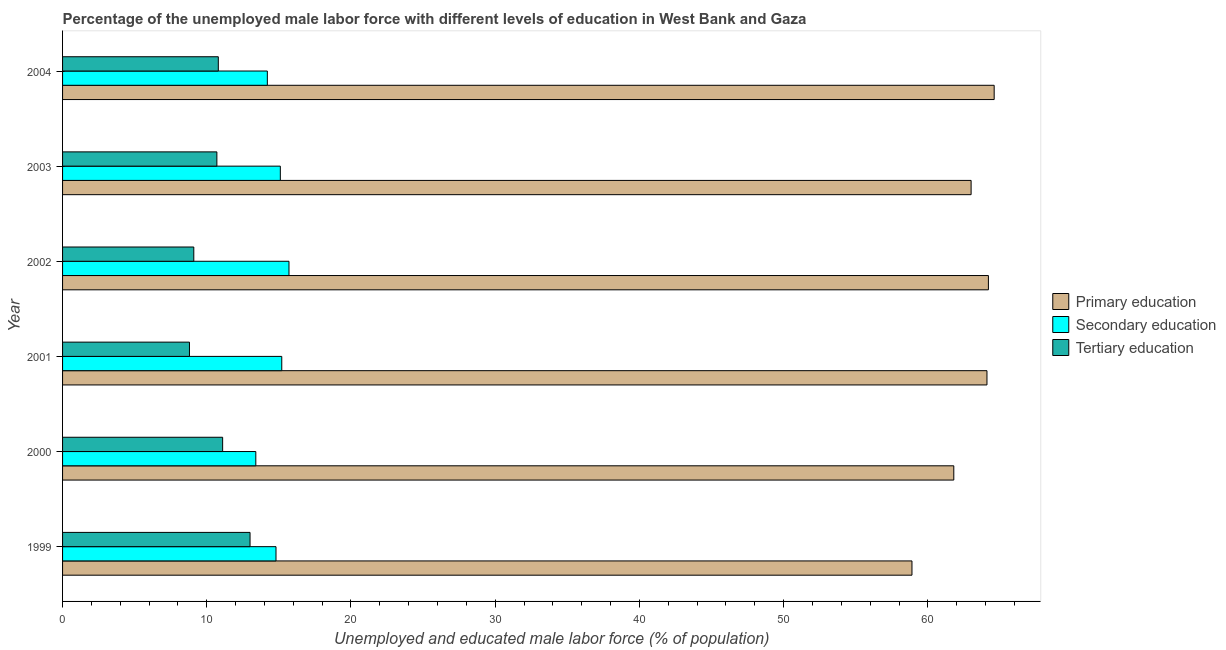How many bars are there on the 2nd tick from the bottom?
Offer a terse response. 3. What is the percentage of male labor force who received primary education in 1999?
Offer a very short reply. 58.9. Across all years, what is the maximum percentage of male labor force who received primary education?
Your answer should be very brief. 64.6. Across all years, what is the minimum percentage of male labor force who received tertiary education?
Provide a short and direct response. 8.8. In which year was the percentage of male labor force who received primary education minimum?
Offer a terse response. 1999. What is the total percentage of male labor force who received tertiary education in the graph?
Offer a terse response. 63.5. What is the difference between the percentage of male labor force who received secondary education in 1999 and that in 2000?
Make the answer very short. 1.4. What is the difference between the percentage of male labor force who received secondary education in 2003 and the percentage of male labor force who received tertiary education in 2004?
Ensure brevity in your answer.  4.3. What is the average percentage of male labor force who received secondary education per year?
Provide a short and direct response. 14.73. In the year 2003, what is the difference between the percentage of male labor force who received tertiary education and percentage of male labor force who received primary education?
Provide a short and direct response. -52.3. What is the ratio of the percentage of male labor force who received secondary education in 2000 to that in 2003?
Ensure brevity in your answer.  0.89. Is the percentage of male labor force who received primary education in 2000 less than that in 2001?
Your answer should be compact. Yes. What is the difference between the highest and the second highest percentage of male labor force who received secondary education?
Make the answer very short. 0.5. In how many years, is the percentage of male labor force who received secondary education greater than the average percentage of male labor force who received secondary education taken over all years?
Keep it short and to the point. 4. Is the sum of the percentage of male labor force who received tertiary education in 2001 and 2002 greater than the maximum percentage of male labor force who received primary education across all years?
Provide a short and direct response. No. What does the 3rd bar from the top in 2002 represents?
Ensure brevity in your answer.  Primary education. What does the 3rd bar from the bottom in 2004 represents?
Provide a short and direct response. Tertiary education. Is it the case that in every year, the sum of the percentage of male labor force who received primary education and percentage of male labor force who received secondary education is greater than the percentage of male labor force who received tertiary education?
Provide a succinct answer. Yes. Are all the bars in the graph horizontal?
Keep it short and to the point. Yes. Are the values on the major ticks of X-axis written in scientific E-notation?
Offer a very short reply. No. Does the graph contain grids?
Ensure brevity in your answer.  No. How many legend labels are there?
Keep it short and to the point. 3. How are the legend labels stacked?
Offer a terse response. Vertical. What is the title of the graph?
Provide a succinct answer. Percentage of the unemployed male labor force with different levels of education in West Bank and Gaza. Does "Wage workers" appear as one of the legend labels in the graph?
Keep it short and to the point. No. What is the label or title of the X-axis?
Offer a terse response. Unemployed and educated male labor force (% of population). What is the Unemployed and educated male labor force (% of population) of Primary education in 1999?
Provide a short and direct response. 58.9. What is the Unemployed and educated male labor force (% of population) of Secondary education in 1999?
Your answer should be compact. 14.8. What is the Unemployed and educated male labor force (% of population) of Primary education in 2000?
Your response must be concise. 61.8. What is the Unemployed and educated male labor force (% of population) of Secondary education in 2000?
Keep it short and to the point. 13.4. What is the Unemployed and educated male labor force (% of population) in Tertiary education in 2000?
Offer a terse response. 11.1. What is the Unemployed and educated male labor force (% of population) in Primary education in 2001?
Provide a short and direct response. 64.1. What is the Unemployed and educated male labor force (% of population) of Secondary education in 2001?
Provide a succinct answer. 15.2. What is the Unemployed and educated male labor force (% of population) of Tertiary education in 2001?
Ensure brevity in your answer.  8.8. What is the Unemployed and educated male labor force (% of population) in Primary education in 2002?
Your answer should be very brief. 64.2. What is the Unemployed and educated male labor force (% of population) of Secondary education in 2002?
Make the answer very short. 15.7. What is the Unemployed and educated male labor force (% of population) in Tertiary education in 2002?
Provide a succinct answer. 9.1. What is the Unemployed and educated male labor force (% of population) in Primary education in 2003?
Provide a short and direct response. 63. What is the Unemployed and educated male labor force (% of population) in Secondary education in 2003?
Keep it short and to the point. 15.1. What is the Unemployed and educated male labor force (% of population) of Tertiary education in 2003?
Make the answer very short. 10.7. What is the Unemployed and educated male labor force (% of population) of Primary education in 2004?
Keep it short and to the point. 64.6. What is the Unemployed and educated male labor force (% of population) in Secondary education in 2004?
Keep it short and to the point. 14.2. What is the Unemployed and educated male labor force (% of population) in Tertiary education in 2004?
Provide a succinct answer. 10.8. Across all years, what is the maximum Unemployed and educated male labor force (% of population) of Primary education?
Make the answer very short. 64.6. Across all years, what is the maximum Unemployed and educated male labor force (% of population) in Secondary education?
Offer a very short reply. 15.7. Across all years, what is the maximum Unemployed and educated male labor force (% of population) in Tertiary education?
Keep it short and to the point. 13. Across all years, what is the minimum Unemployed and educated male labor force (% of population) in Primary education?
Give a very brief answer. 58.9. Across all years, what is the minimum Unemployed and educated male labor force (% of population) of Secondary education?
Provide a short and direct response. 13.4. Across all years, what is the minimum Unemployed and educated male labor force (% of population) in Tertiary education?
Give a very brief answer. 8.8. What is the total Unemployed and educated male labor force (% of population) of Primary education in the graph?
Offer a terse response. 376.6. What is the total Unemployed and educated male labor force (% of population) in Secondary education in the graph?
Keep it short and to the point. 88.4. What is the total Unemployed and educated male labor force (% of population) in Tertiary education in the graph?
Provide a succinct answer. 63.5. What is the difference between the Unemployed and educated male labor force (% of population) in Primary education in 1999 and that in 2000?
Offer a very short reply. -2.9. What is the difference between the Unemployed and educated male labor force (% of population) of Secondary education in 1999 and that in 2000?
Provide a succinct answer. 1.4. What is the difference between the Unemployed and educated male labor force (% of population) in Tertiary education in 1999 and that in 2000?
Your answer should be very brief. 1.9. What is the difference between the Unemployed and educated male labor force (% of population) in Primary education in 1999 and that in 2001?
Make the answer very short. -5.2. What is the difference between the Unemployed and educated male labor force (% of population) in Secondary education in 1999 and that in 2001?
Ensure brevity in your answer.  -0.4. What is the difference between the Unemployed and educated male labor force (% of population) of Tertiary education in 1999 and that in 2001?
Provide a short and direct response. 4.2. What is the difference between the Unemployed and educated male labor force (% of population) of Primary education in 1999 and that in 2002?
Provide a succinct answer. -5.3. What is the difference between the Unemployed and educated male labor force (% of population) in Secondary education in 1999 and that in 2003?
Provide a succinct answer. -0.3. What is the difference between the Unemployed and educated male labor force (% of population) in Tertiary education in 1999 and that in 2004?
Your answer should be very brief. 2.2. What is the difference between the Unemployed and educated male labor force (% of population) of Primary education in 2000 and that in 2002?
Provide a succinct answer. -2.4. What is the difference between the Unemployed and educated male labor force (% of population) of Tertiary education in 2000 and that in 2002?
Give a very brief answer. 2. What is the difference between the Unemployed and educated male labor force (% of population) of Primary education in 2000 and that in 2003?
Offer a very short reply. -1.2. What is the difference between the Unemployed and educated male labor force (% of population) in Primary education in 2000 and that in 2004?
Provide a short and direct response. -2.8. What is the difference between the Unemployed and educated male labor force (% of population) of Secondary education in 2001 and that in 2002?
Provide a succinct answer. -0.5. What is the difference between the Unemployed and educated male labor force (% of population) of Tertiary education in 2001 and that in 2002?
Give a very brief answer. -0.3. What is the difference between the Unemployed and educated male labor force (% of population) in Tertiary education in 2001 and that in 2004?
Keep it short and to the point. -2. What is the difference between the Unemployed and educated male labor force (% of population) in Primary education in 2002 and that in 2003?
Give a very brief answer. 1.2. What is the difference between the Unemployed and educated male labor force (% of population) in Secondary education in 2002 and that in 2003?
Make the answer very short. 0.6. What is the difference between the Unemployed and educated male labor force (% of population) in Tertiary education in 2002 and that in 2003?
Provide a short and direct response. -1.6. What is the difference between the Unemployed and educated male labor force (% of population) of Primary education in 2002 and that in 2004?
Offer a terse response. -0.4. What is the difference between the Unemployed and educated male labor force (% of population) in Secondary education in 2002 and that in 2004?
Your answer should be compact. 1.5. What is the difference between the Unemployed and educated male labor force (% of population) of Tertiary education in 2002 and that in 2004?
Provide a succinct answer. -1.7. What is the difference between the Unemployed and educated male labor force (% of population) in Secondary education in 2003 and that in 2004?
Keep it short and to the point. 0.9. What is the difference between the Unemployed and educated male labor force (% of population) of Primary education in 1999 and the Unemployed and educated male labor force (% of population) of Secondary education in 2000?
Offer a terse response. 45.5. What is the difference between the Unemployed and educated male labor force (% of population) of Primary education in 1999 and the Unemployed and educated male labor force (% of population) of Tertiary education in 2000?
Provide a short and direct response. 47.8. What is the difference between the Unemployed and educated male labor force (% of population) of Primary education in 1999 and the Unemployed and educated male labor force (% of population) of Secondary education in 2001?
Keep it short and to the point. 43.7. What is the difference between the Unemployed and educated male labor force (% of population) in Primary education in 1999 and the Unemployed and educated male labor force (% of population) in Tertiary education in 2001?
Keep it short and to the point. 50.1. What is the difference between the Unemployed and educated male labor force (% of population) of Primary education in 1999 and the Unemployed and educated male labor force (% of population) of Secondary education in 2002?
Give a very brief answer. 43.2. What is the difference between the Unemployed and educated male labor force (% of population) of Primary education in 1999 and the Unemployed and educated male labor force (% of population) of Tertiary education in 2002?
Give a very brief answer. 49.8. What is the difference between the Unemployed and educated male labor force (% of population) of Secondary education in 1999 and the Unemployed and educated male labor force (% of population) of Tertiary education in 2002?
Offer a terse response. 5.7. What is the difference between the Unemployed and educated male labor force (% of population) in Primary education in 1999 and the Unemployed and educated male labor force (% of population) in Secondary education in 2003?
Offer a terse response. 43.8. What is the difference between the Unemployed and educated male labor force (% of population) of Primary education in 1999 and the Unemployed and educated male labor force (% of population) of Tertiary education in 2003?
Your answer should be compact. 48.2. What is the difference between the Unemployed and educated male labor force (% of population) of Primary education in 1999 and the Unemployed and educated male labor force (% of population) of Secondary education in 2004?
Provide a succinct answer. 44.7. What is the difference between the Unemployed and educated male labor force (% of population) in Primary education in 1999 and the Unemployed and educated male labor force (% of population) in Tertiary education in 2004?
Give a very brief answer. 48.1. What is the difference between the Unemployed and educated male labor force (% of population) of Secondary education in 1999 and the Unemployed and educated male labor force (% of population) of Tertiary education in 2004?
Ensure brevity in your answer.  4. What is the difference between the Unemployed and educated male labor force (% of population) in Primary education in 2000 and the Unemployed and educated male labor force (% of population) in Secondary education in 2001?
Offer a very short reply. 46.6. What is the difference between the Unemployed and educated male labor force (% of population) in Primary education in 2000 and the Unemployed and educated male labor force (% of population) in Secondary education in 2002?
Provide a short and direct response. 46.1. What is the difference between the Unemployed and educated male labor force (% of population) of Primary education in 2000 and the Unemployed and educated male labor force (% of population) of Tertiary education in 2002?
Offer a terse response. 52.7. What is the difference between the Unemployed and educated male labor force (% of population) in Primary education in 2000 and the Unemployed and educated male labor force (% of population) in Secondary education in 2003?
Offer a very short reply. 46.7. What is the difference between the Unemployed and educated male labor force (% of population) in Primary education in 2000 and the Unemployed and educated male labor force (% of population) in Tertiary education in 2003?
Provide a succinct answer. 51.1. What is the difference between the Unemployed and educated male labor force (% of population) in Primary education in 2000 and the Unemployed and educated male labor force (% of population) in Secondary education in 2004?
Your answer should be compact. 47.6. What is the difference between the Unemployed and educated male labor force (% of population) of Primary education in 2001 and the Unemployed and educated male labor force (% of population) of Secondary education in 2002?
Ensure brevity in your answer.  48.4. What is the difference between the Unemployed and educated male labor force (% of population) in Primary education in 2001 and the Unemployed and educated male labor force (% of population) in Secondary education in 2003?
Make the answer very short. 49. What is the difference between the Unemployed and educated male labor force (% of population) in Primary education in 2001 and the Unemployed and educated male labor force (% of population) in Tertiary education in 2003?
Your response must be concise. 53.4. What is the difference between the Unemployed and educated male labor force (% of population) of Secondary education in 2001 and the Unemployed and educated male labor force (% of population) of Tertiary education in 2003?
Your answer should be very brief. 4.5. What is the difference between the Unemployed and educated male labor force (% of population) of Primary education in 2001 and the Unemployed and educated male labor force (% of population) of Secondary education in 2004?
Your answer should be compact. 49.9. What is the difference between the Unemployed and educated male labor force (% of population) of Primary education in 2001 and the Unemployed and educated male labor force (% of population) of Tertiary education in 2004?
Your answer should be compact. 53.3. What is the difference between the Unemployed and educated male labor force (% of population) of Secondary education in 2001 and the Unemployed and educated male labor force (% of population) of Tertiary education in 2004?
Your answer should be very brief. 4.4. What is the difference between the Unemployed and educated male labor force (% of population) in Primary education in 2002 and the Unemployed and educated male labor force (% of population) in Secondary education in 2003?
Your response must be concise. 49.1. What is the difference between the Unemployed and educated male labor force (% of population) of Primary education in 2002 and the Unemployed and educated male labor force (% of population) of Tertiary education in 2003?
Ensure brevity in your answer.  53.5. What is the difference between the Unemployed and educated male labor force (% of population) of Secondary education in 2002 and the Unemployed and educated male labor force (% of population) of Tertiary education in 2003?
Give a very brief answer. 5. What is the difference between the Unemployed and educated male labor force (% of population) of Primary education in 2002 and the Unemployed and educated male labor force (% of population) of Secondary education in 2004?
Ensure brevity in your answer.  50. What is the difference between the Unemployed and educated male labor force (% of population) of Primary education in 2002 and the Unemployed and educated male labor force (% of population) of Tertiary education in 2004?
Your answer should be very brief. 53.4. What is the difference between the Unemployed and educated male labor force (% of population) in Secondary education in 2002 and the Unemployed and educated male labor force (% of population) in Tertiary education in 2004?
Give a very brief answer. 4.9. What is the difference between the Unemployed and educated male labor force (% of population) in Primary education in 2003 and the Unemployed and educated male labor force (% of population) in Secondary education in 2004?
Keep it short and to the point. 48.8. What is the difference between the Unemployed and educated male labor force (% of population) of Primary education in 2003 and the Unemployed and educated male labor force (% of population) of Tertiary education in 2004?
Offer a very short reply. 52.2. What is the average Unemployed and educated male labor force (% of population) of Primary education per year?
Offer a very short reply. 62.77. What is the average Unemployed and educated male labor force (% of population) of Secondary education per year?
Make the answer very short. 14.73. What is the average Unemployed and educated male labor force (% of population) of Tertiary education per year?
Keep it short and to the point. 10.58. In the year 1999, what is the difference between the Unemployed and educated male labor force (% of population) in Primary education and Unemployed and educated male labor force (% of population) in Secondary education?
Give a very brief answer. 44.1. In the year 1999, what is the difference between the Unemployed and educated male labor force (% of population) in Primary education and Unemployed and educated male labor force (% of population) in Tertiary education?
Make the answer very short. 45.9. In the year 2000, what is the difference between the Unemployed and educated male labor force (% of population) of Primary education and Unemployed and educated male labor force (% of population) of Secondary education?
Give a very brief answer. 48.4. In the year 2000, what is the difference between the Unemployed and educated male labor force (% of population) of Primary education and Unemployed and educated male labor force (% of population) of Tertiary education?
Your response must be concise. 50.7. In the year 2000, what is the difference between the Unemployed and educated male labor force (% of population) of Secondary education and Unemployed and educated male labor force (% of population) of Tertiary education?
Ensure brevity in your answer.  2.3. In the year 2001, what is the difference between the Unemployed and educated male labor force (% of population) in Primary education and Unemployed and educated male labor force (% of population) in Secondary education?
Your response must be concise. 48.9. In the year 2001, what is the difference between the Unemployed and educated male labor force (% of population) of Primary education and Unemployed and educated male labor force (% of population) of Tertiary education?
Offer a very short reply. 55.3. In the year 2002, what is the difference between the Unemployed and educated male labor force (% of population) in Primary education and Unemployed and educated male labor force (% of population) in Secondary education?
Give a very brief answer. 48.5. In the year 2002, what is the difference between the Unemployed and educated male labor force (% of population) of Primary education and Unemployed and educated male labor force (% of population) of Tertiary education?
Your answer should be very brief. 55.1. In the year 2002, what is the difference between the Unemployed and educated male labor force (% of population) in Secondary education and Unemployed and educated male labor force (% of population) in Tertiary education?
Provide a short and direct response. 6.6. In the year 2003, what is the difference between the Unemployed and educated male labor force (% of population) in Primary education and Unemployed and educated male labor force (% of population) in Secondary education?
Make the answer very short. 47.9. In the year 2003, what is the difference between the Unemployed and educated male labor force (% of population) of Primary education and Unemployed and educated male labor force (% of population) of Tertiary education?
Your response must be concise. 52.3. In the year 2004, what is the difference between the Unemployed and educated male labor force (% of population) of Primary education and Unemployed and educated male labor force (% of population) of Secondary education?
Your answer should be compact. 50.4. In the year 2004, what is the difference between the Unemployed and educated male labor force (% of population) in Primary education and Unemployed and educated male labor force (% of population) in Tertiary education?
Give a very brief answer. 53.8. In the year 2004, what is the difference between the Unemployed and educated male labor force (% of population) in Secondary education and Unemployed and educated male labor force (% of population) in Tertiary education?
Offer a very short reply. 3.4. What is the ratio of the Unemployed and educated male labor force (% of population) in Primary education in 1999 to that in 2000?
Provide a short and direct response. 0.95. What is the ratio of the Unemployed and educated male labor force (% of population) in Secondary education in 1999 to that in 2000?
Provide a succinct answer. 1.1. What is the ratio of the Unemployed and educated male labor force (% of population) of Tertiary education in 1999 to that in 2000?
Your answer should be very brief. 1.17. What is the ratio of the Unemployed and educated male labor force (% of population) of Primary education in 1999 to that in 2001?
Ensure brevity in your answer.  0.92. What is the ratio of the Unemployed and educated male labor force (% of population) of Secondary education in 1999 to that in 2001?
Your answer should be compact. 0.97. What is the ratio of the Unemployed and educated male labor force (% of population) in Tertiary education in 1999 to that in 2001?
Provide a succinct answer. 1.48. What is the ratio of the Unemployed and educated male labor force (% of population) of Primary education in 1999 to that in 2002?
Your answer should be compact. 0.92. What is the ratio of the Unemployed and educated male labor force (% of population) of Secondary education in 1999 to that in 2002?
Your answer should be very brief. 0.94. What is the ratio of the Unemployed and educated male labor force (% of population) of Tertiary education in 1999 to that in 2002?
Ensure brevity in your answer.  1.43. What is the ratio of the Unemployed and educated male labor force (% of population) of Primary education in 1999 to that in 2003?
Your answer should be compact. 0.93. What is the ratio of the Unemployed and educated male labor force (% of population) of Secondary education in 1999 to that in 2003?
Offer a very short reply. 0.98. What is the ratio of the Unemployed and educated male labor force (% of population) in Tertiary education in 1999 to that in 2003?
Offer a terse response. 1.22. What is the ratio of the Unemployed and educated male labor force (% of population) of Primary education in 1999 to that in 2004?
Keep it short and to the point. 0.91. What is the ratio of the Unemployed and educated male labor force (% of population) in Secondary education in 1999 to that in 2004?
Your answer should be very brief. 1.04. What is the ratio of the Unemployed and educated male labor force (% of population) in Tertiary education in 1999 to that in 2004?
Provide a succinct answer. 1.2. What is the ratio of the Unemployed and educated male labor force (% of population) of Primary education in 2000 to that in 2001?
Provide a short and direct response. 0.96. What is the ratio of the Unemployed and educated male labor force (% of population) in Secondary education in 2000 to that in 2001?
Offer a terse response. 0.88. What is the ratio of the Unemployed and educated male labor force (% of population) in Tertiary education in 2000 to that in 2001?
Provide a succinct answer. 1.26. What is the ratio of the Unemployed and educated male labor force (% of population) in Primary education in 2000 to that in 2002?
Keep it short and to the point. 0.96. What is the ratio of the Unemployed and educated male labor force (% of population) in Secondary education in 2000 to that in 2002?
Provide a succinct answer. 0.85. What is the ratio of the Unemployed and educated male labor force (% of population) in Tertiary education in 2000 to that in 2002?
Your response must be concise. 1.22. What is the ratio of the Unemployed and educated male labor force (% of population) in Primary education in 2000 to that in 2003?
Give a very brief answer. 0.98. What is the ratio of the Unemployed and educated male labor force (% of population) in Secondary education in 2000 to that in 2003?
Provide a short and direct response. 0.89. What is the ratio of the Unemployed and educated male labor force (% of population) of Tertiary education in 2000 to that in 2003?
Your answer should be compact. 1.04. What is the ratio of the Unemployed and educated male labor force (% of population) of Primary education in 2000 to that in 2004?
Provide a short and direct response. 0.96. What is the ratio of the Unemployed and educated male labor force (% of population) in Secondary education in 2000 to that in 2004?
Ensure brevity in your answer.  0.94. What is the ratio of the Unemployed and educated male labor force (% of population) in Tertiary education in 2000 to that in 2004?
Offer a very short reply. 1.03. What is the ratio of the Unemployed and educated male labor force (% of population) of Secondary education in 2001 to that in 2002?
Offer a very short reply. 0.97. What is the ratio of the Unemployed and educated male labor force (% of population) in Tertiary education in 2001 to that in 2002?
Provide a short and direct response. 0.97. What is the ratio of the Unemployed and educated male labor force (% of population) in Primary education in 2001 to that in 2003?
Keep it short and to the point. 1.02. What is the ratio of the Unemployed and educated male labor force (% of population) of Secondary education in 2001 to that in 2003?
Ensure brevity in your answer.  1.01. What is the ratio of the Unemployed and educated male labor force (% of population) of Tertiary education in 2001 to that in 2003?
Ensure brevity in your answer.  0.82. What is the ratio of the Unemployed and educated male labor force (% of population) of Primary education in 2001 to that in 2004?
Your answer should be compact. 0.99. What is the ratio of the Unemployed and educated male labor force (% of population) of Secondary education in 2001 to that in 2004?
Your answer should be very brief. 1.07. What is the ratio of the Unemployed and educated male labor force (% of population) of Tertiary education in 2001 to that in 2004?
Offer a very short reply. 0.81. What is the ratio of the Unemployed and educated male labor force (% of population) in Secondary education in 2002 to that in 2003?
Make the answer very short. 1.04. What is the ratio of the Unemployed and educated male labor force (% of population) in Tertiary education in 2002 to that in 2003?
Your answer should be compact. 0.85. What is the ratio of the Unemployed and educated male labor force (% of population) in Primary education in 2002 to that in 2004?
Your response must be concise. 0.99. What is the ratio of the Unemployed and educated male labor force (% of population) in Secondary education in 2002 to that in 2004?
Ensure brevity in your answer.  1.11. What is the ratio of the Unemployed and educated male labor force (% of population) of Tertiary education in 2002 to that in 2004?
Make the answer very short. 0.84. What is the ratio of the Unemployed and educated male labor force (% of population) of Primary education in 2003 to that in 2004?
Your answer should be compact. 0.98. What is the ratio of the Unemployed and educated male labor force (% of population) of Secondary education in 2003 to that in 2004?
Make the answer very short. 1.06. What is the ratio of the Unemployed and educated male labor force (% of population) of Tertiary education in 2003 to that in 2004?
Provide a short and direct response. 0.99. What is the difference between the highest and the second highest Unemployed and educated male labor force (% of population) in Secondary education?
Your answer should be compact. 0.5. What is the difference between the highest and the lowest Unemployed and educated male labor force (% of population) in Primary education?
Your response must be concise. 5.7. What is the difference between the highest and the lowest Unemployed and educated male labor force (% of population) of Secondary education?
Offer a very short reply. 2.3. 